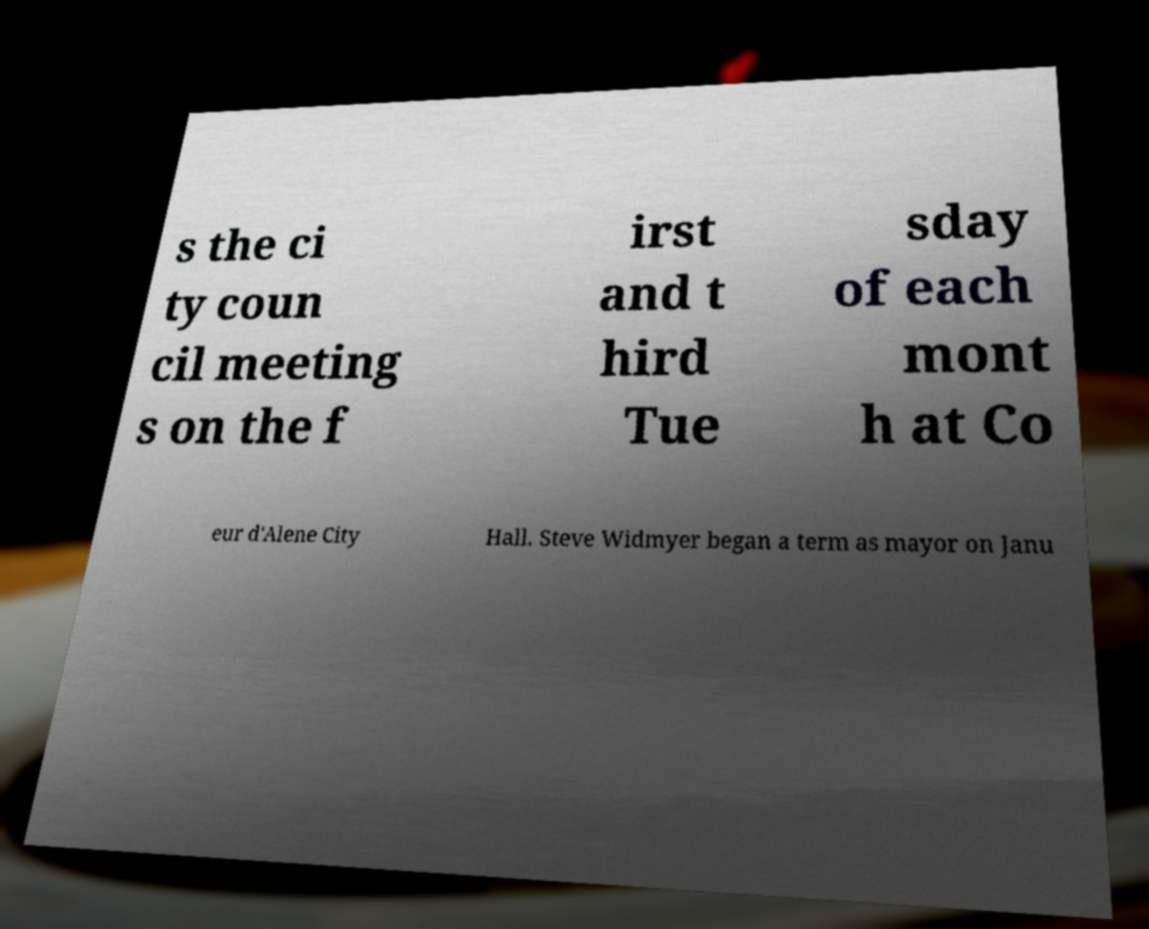Please read and relay the text visible in this image. What does it say? s the ci ty coun cil meeting s on the f irst and t hird Tue sday of each mont h at Co eur d'Alene City Hall. Steve Widmyer began a term as mayor on Janu 